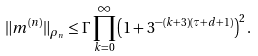Convert formula to latex. <formula><loc_0><loc_0><loc_500><loc_500>\| m ^ { ( n ) } \| _ { \rho _ { n } } \leq \Gamma \prod _ { k = 0 } ^ { \infty } \left ( 1 + 3 ^ { - ( k + 3 ) ( \tau + d + 1 ) } \right ) ^ { 2 } .</formula> 